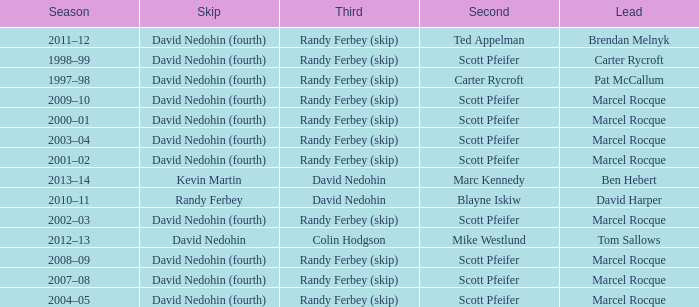Which Second has a Lead of ben hebert? Marc Kennedy. 